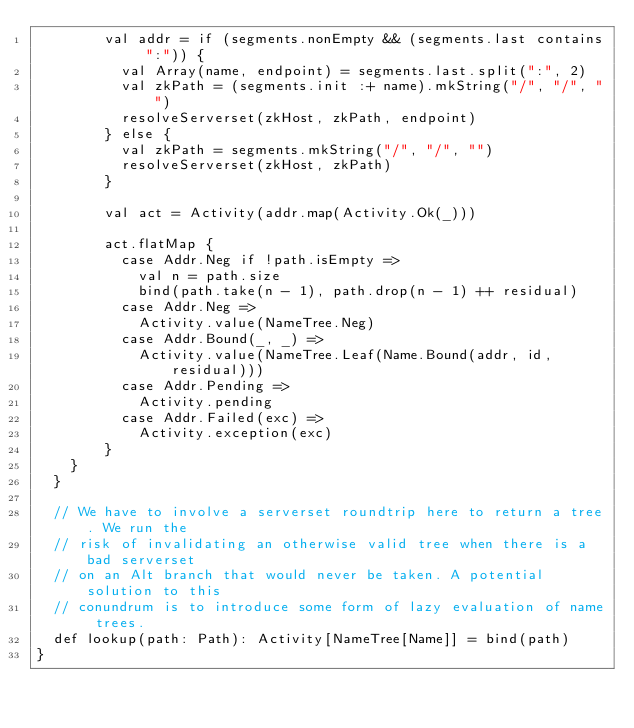<code> <loc_0><loc_0><loc_500><loc_500><_Scala_>        val addr = if (segments.nonEmpty && (segments.last contains ":")) {
          val Array(name, endpoint) = segments.last.split(":", 2)
          val zkPath = (segments.init :+ name).mkString("/", "/", "")
          resolveServerset(zkHost, zkPath, endpoint)
        } else {
          val zkPath = segments.mkString("/", "/", "")
          resolveServerset(zkHost, zkPath)
        }

        val act = Activity(addr.map(Activity.Ok(_)))

        act.flatMap {
          case Addr.Neg if !path.isEmpty =>
            val n = path.size
            bind(path.take(n - 1), path.drop(n - 1) ++ residual)
          case Addr.Neg =>
            Activity.value(NameTree.Neg)
          case Addr.Bound(_, _) =>
            Activity.value(NameTree.Leaf(Name.Bound(addr, id, residual)))
          case Addr.Pending =>
            Activity.pending
          case Addr.Failed(exc) =>
            Activity.exception(exc)
        }
    }
  }

  // We have to involve a serverset roundtrip here to return a tree. We run the
  // risk of invalidating an otherwise valid tree when there is a bad serverset
  // on an Alt branch that would never be taken. A potential solution to this
  // conundrum is to introduce some form of lazy evaluation of name trees.
  def lookup(path: Path): Activity[NameTree[Name]] = bind(path)
}
</code> 